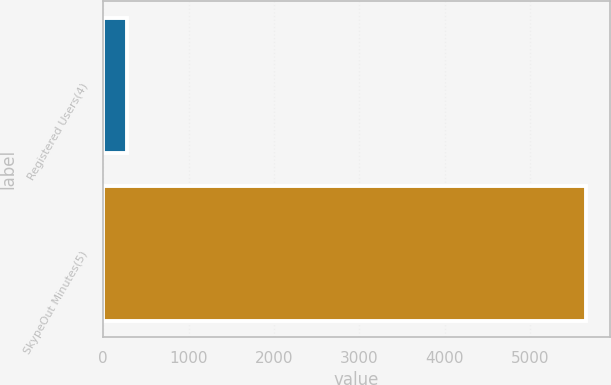<chart> <loc_0><loc_0><loc_500><loc_500><bar_chart><fcel>Registered Users(4)<fcel>SkypeOut Minutes(5)<nl><fcel>276.3<fcel>5650<nl></chart> 